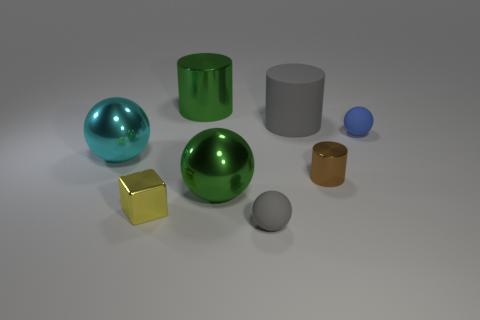Subtract all gray matte cylinders. How many cylinders are left? 2 Subtract all brown cylinders. How many cylinders are left? 2 Subtract 2 cylinders. How many cylinders are left? 1 Add 1 big cyan spheres. How many objects exist? 9 Add 7 large yellow matte cubes. How many large yellow matte cubes exist? 7 Subtract 1 cyan spheres. How many objects are left? 7 Subtract all cylinders. How many objects are left? 5 Subtract all red blocks. Subtract all purple spheres. How many blocks are left? 1 Subtract all red blocks. How many brown cylinders are left? 1 Subtract all green cylinders. Subtract all big balls. How many objects are left? 5 